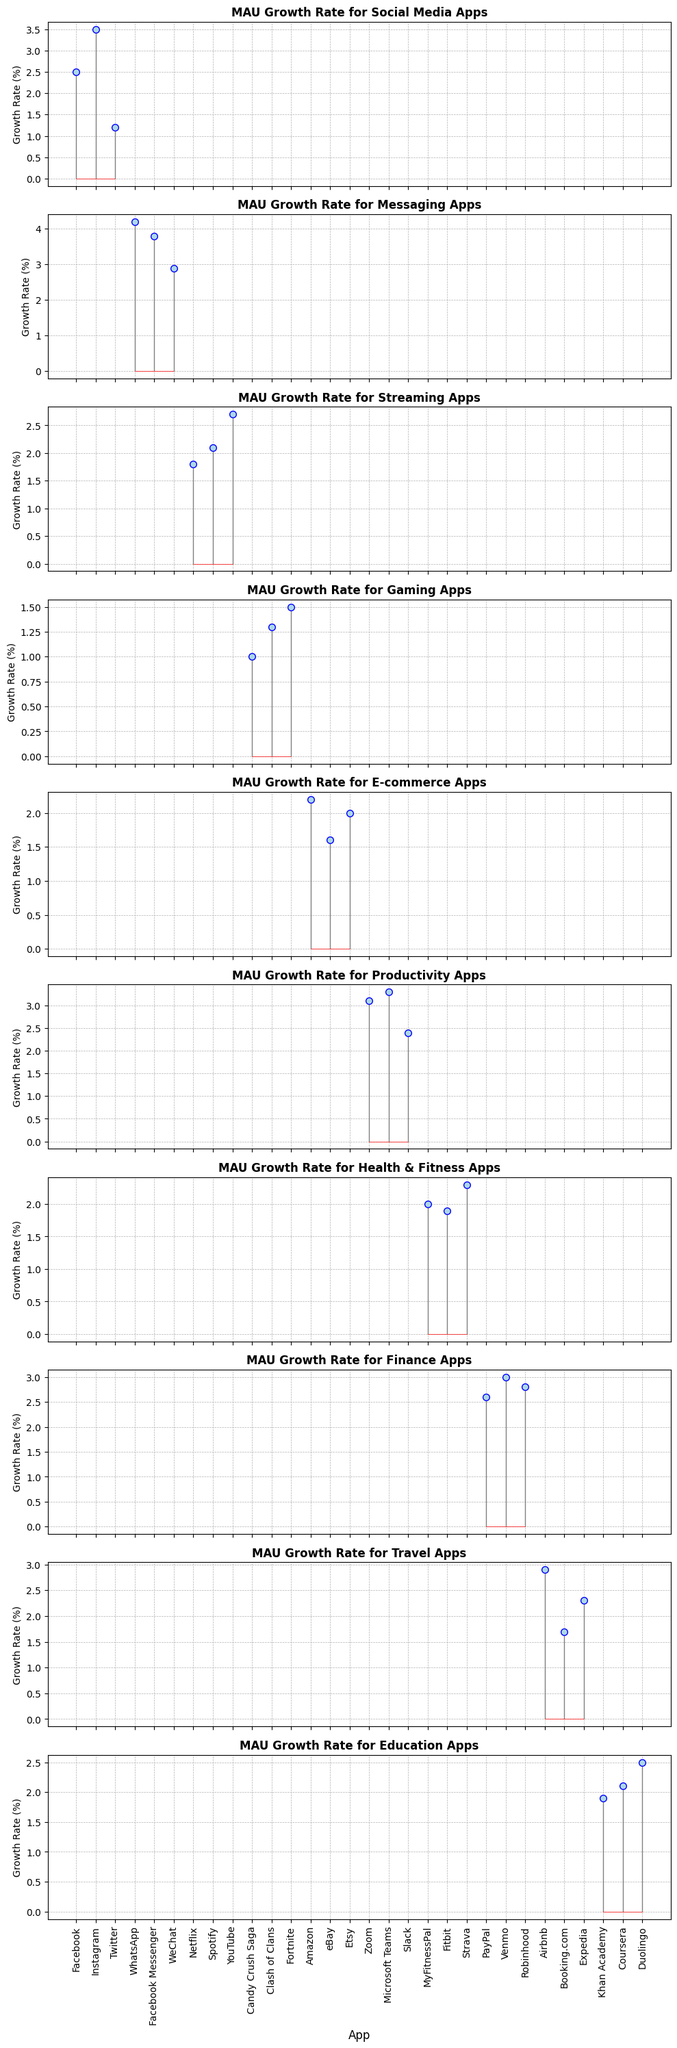Which category has the highest average MAU growth rate? First, calculate the average growth rate for each category by summing the growth rates and dividing by the number of apps in each category. Then, compare these averages.
Answer: Messaging (3.63%) Which app has the highest growth rate in the Social Media category? Look at the Social Media category and compare the growth rates of Facebook, Instagram, and Twitter.
Answer: Instagram (3.5%) What is the difference in growth rate between WhatsApp and Facebook Messenger in the Messaging category? Subtract the growth rate of Facebook Messenger from WhatsApp. WhatsApp (4.2%) - Facebook Messenger (3.8%) = 0.4%.
Answer: 0.4% Among the E-commerce apps, which one has the lowest MAU growth rate? Compare the growth rates of Amazon, eBay, and Etsy in the E-commerce category.
Answer: eBay (1.6%) What's the average growth rate of the Gaming apps? Sum the growth rates of Candy Crush Saga, Clash of Clans, and Fortnite, then divide by the number of apps. (1.0 + 1.3 + 1.5) / 3 = 1.27%.
Answer: 1.27% Which app in the Finance category has a growth rate closest to the overall average growth rate of all apps? First, calculate the overall average growth rate by summing all growth rates and dividing by the number of apps. Then, find the Finance app whose growth rate is closest to this average.
Answer: Robinhood (2.8%) Is the growth rate of YouTube higher than the average growth rate of Streaming apps? Calculate the average growth rate for the Streaming category, and compare it with YouTube's growth rate. Average for Streaming: (1.8 + 2.1 + 2.7) / 3 = 2.2%. YouTube's growth rate is higher at 2.7%.
Answer: Yes How does the growth rate of Duolingo in the Education category compare to the growth rate of Facebook in the Social Media category? Compare the growth rates: Duolingo (2.5%) and Facebook (2.5%).
Answer: Equal What's the combined growth rate of Airbnb and Booking.com in the Travel category? Add the growth rates of Airbnb (2.9%) and Booking.com (1.7%). 2.9% + 1.7% = 4.6%.
Answer: 4.6% Which category has the most apps with a growth rate higher than 2.0%? Count the number of apps in each category with a growth rate higher than 2.0% and compare these counts.
Answer: Productivity (3 apps: Zoom, Microsoft Teams, and Slack) 